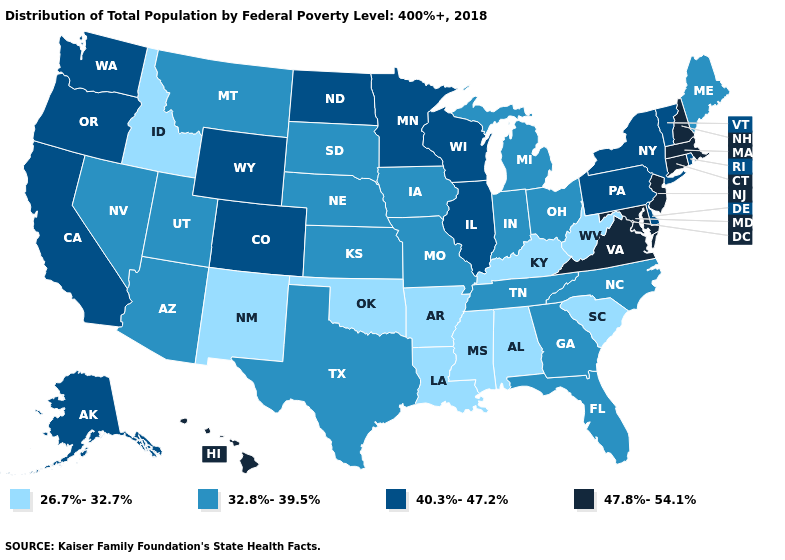Name the states that have a value in the range 40.3%-47.2%?
Short answer required. Alaska, California, Colorado, Delaware, Illinois, Minnesota, New York, North Dakota, Oregon, Pennsylvania, Rhode Island, Vermont, Washington, Wisconsin, Wyoming. What is the highest value in the MidWest ?
Answer briefly. 40.3%-47.2%. Is the legend a continuous bar?
Keep it brief. No. Does New Hampshire have the highest value in the USA?
Short answer required. Yes. What is the value of Vermont?
Write a very short answer. 40.3%-47.2%. Is the legend a continuous bar?
Concise answer only. No. What is the value of Tennessee?
Be succinct. 32.8%-39.5%. What is the lowest value in the South?
Keep it brief. 26.7%-32.7%. Among the states that border Connecticut , which have the highest value?
Answer briefly. Massachusetts. What is the value of Mississippi?
Answer briefly. 26.7%-32.7%. What is the value of North Carolina?
Short answer required. 32.8%-39.5%. What is the value of Kansas?
Be succinct. 32.8%-39.5%. What is the value of Texas?
Answer briefly. 32.8%-39.5%. Name the states that have a value in the range 40.3%-47.2%?
Give a very brief answer. Alaska, California, Colorado, Delaware, Illinois, Minnesota, New York, North Dakota, Oregon, Pennsylvania, Rhode Island, Vermont, Washington, Wisconsin, Wyoming. Does South Dakota have a higher value than California?
Concise answer only. No. 